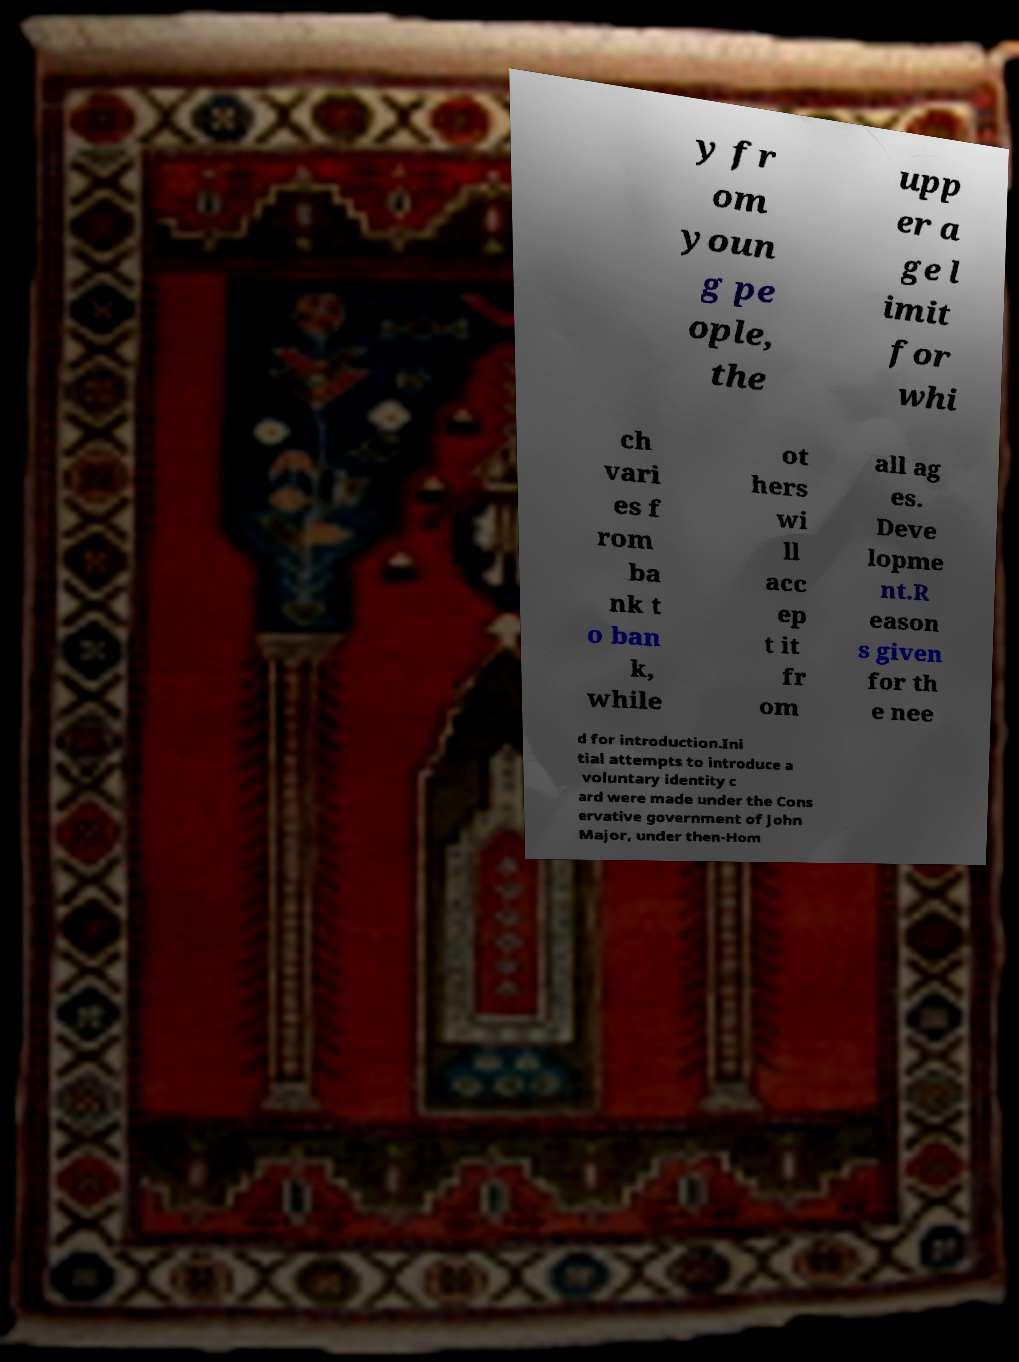Can you accurately transcribe the text from the provided image for me? y fr om youn g pe ople, the upp er a ge l imit for whi ch vari es f rom ba nk t o ban k, while ot hers wi ll acc ep t it fr om all ag es. Deve lopme nt.R eason s given for th e nee d for introduction.Ini tial attempts to introduce a voluntary identity c ard were made under the Cons ervative government of John Major, under then-Hom 